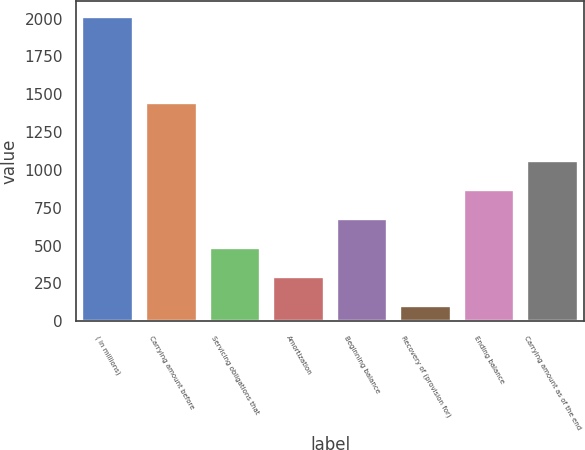Convert chart to OTSL. <chart><loc_0><loc_0><loc_500><loc_500><bar_chart><fcel>( in millions)<fcel>Carrying amount before<fcel>Servicing obligations that<fcel>Amortization<fcel>Beginning balance<fcel>Recovery of (provision for)<fcel>Ending balance<fcel>Carrying amount as of the end<nl><fcel>2012<fcel>1439.3<fcel>484.8<fcel>293.9<fcel>675.7<fcel>103<fcel>866.6<fcel>1057.5<nl></chart> 